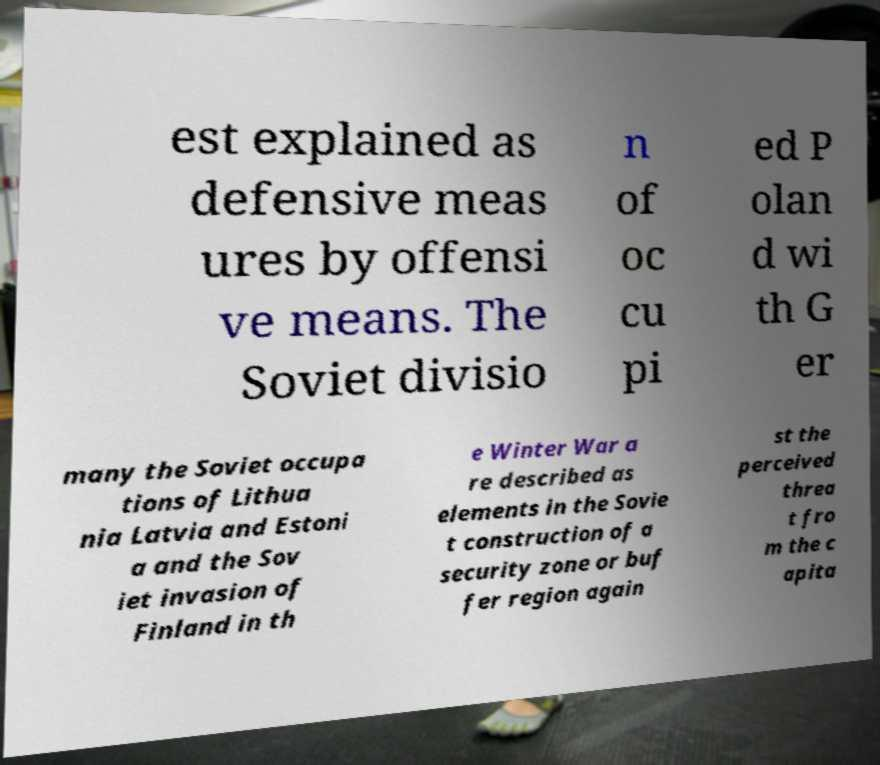Can you read and provide the text displayed in the image?This photo seems to have some interesting text. Can you extract and type it out for me? est explained as defensive meas ures by offensi ve means. The Soviet divisio n of oc cu pi ed P olan d wi th G er many the Soviet occupa tions of Lithua nia Latvia and Estoni a and the Sov iet invasion of Finland in th e Winter War a re described as elements in the Sovie t construction of a security zone or buf fer region again st the perceived threa t fro m the c apita 